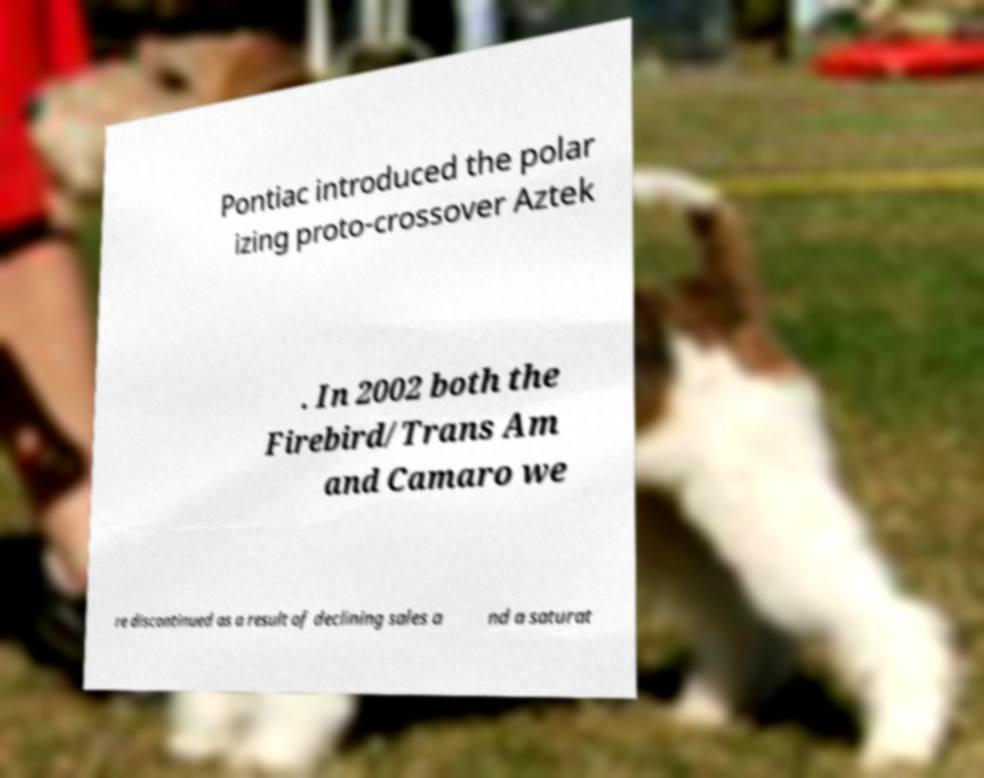Please read and relay the text visible in this image. What does it say? Pontiac introduced the polar izing proto-crossover Aztek . In 2002 both the Firebird/Trans Am and Camaro we re discontinued as a result of declining sales a nd a saturat 